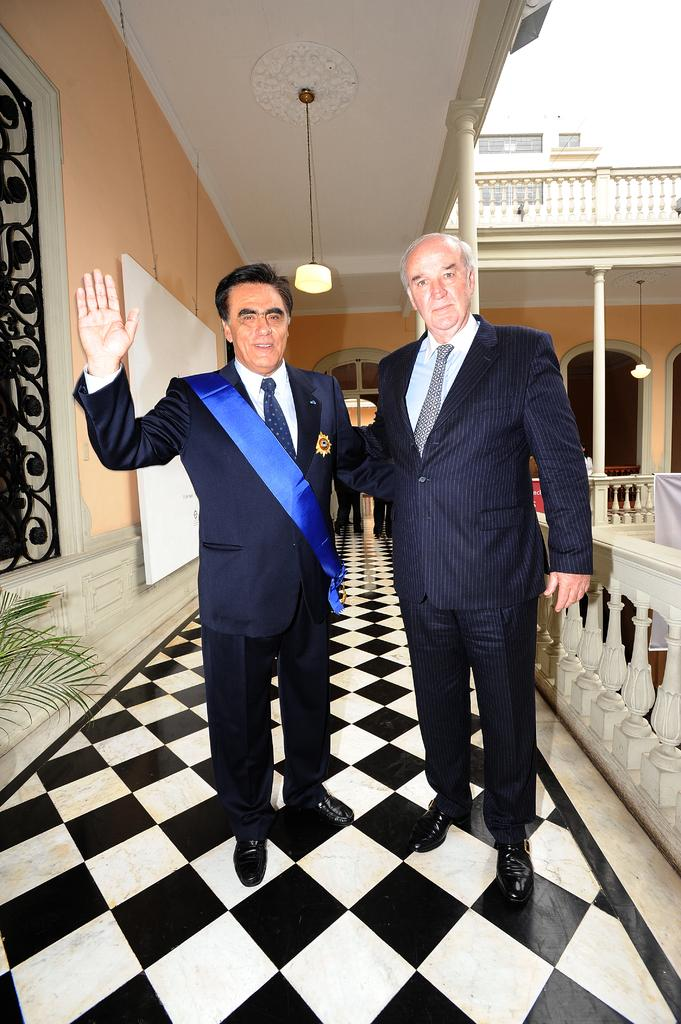How many people are in the image? There are two persons standing in the image. Can you describe the attire of one of the persons? One person is wearing a sash. What other objects can be seen in the image? There is a plant, a board, a banner, lights, pillars, and a building in the image. What type of mark does the cheese leave on the banner in the image? There is no cheese present in the image, so it cannot leave a mark on the banner. 